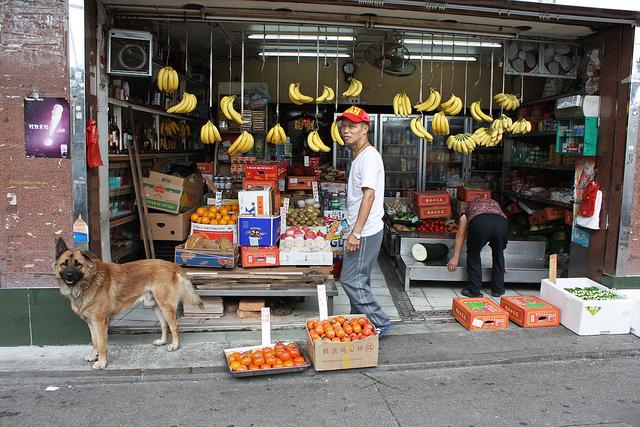Is the dog eating the fruit?
Answer briefly. No. How many boxes of tomatoes are on the street?
Write a very short answer. 2. Which way is the dog looking?
Answer briefly. Left. What fruit is hanging?
Give a very brief answer. Bananas. 